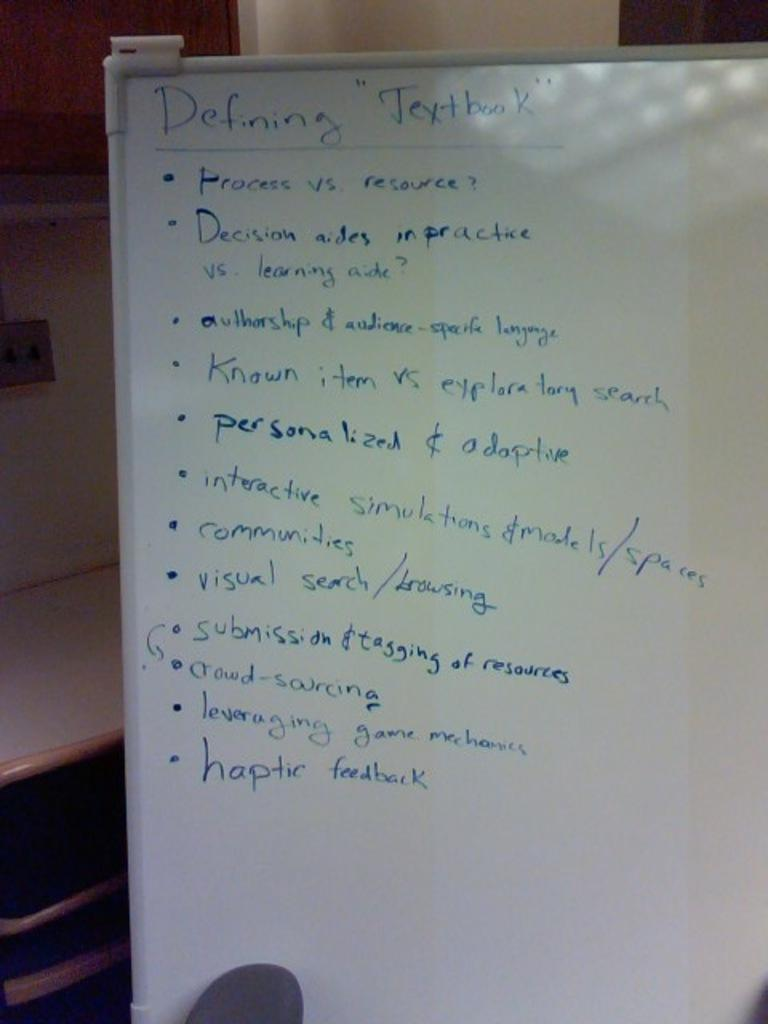Provide a one-sentence caption for the provided image. A whiteboard that has notes written down under the headline of Defining Textbook. 